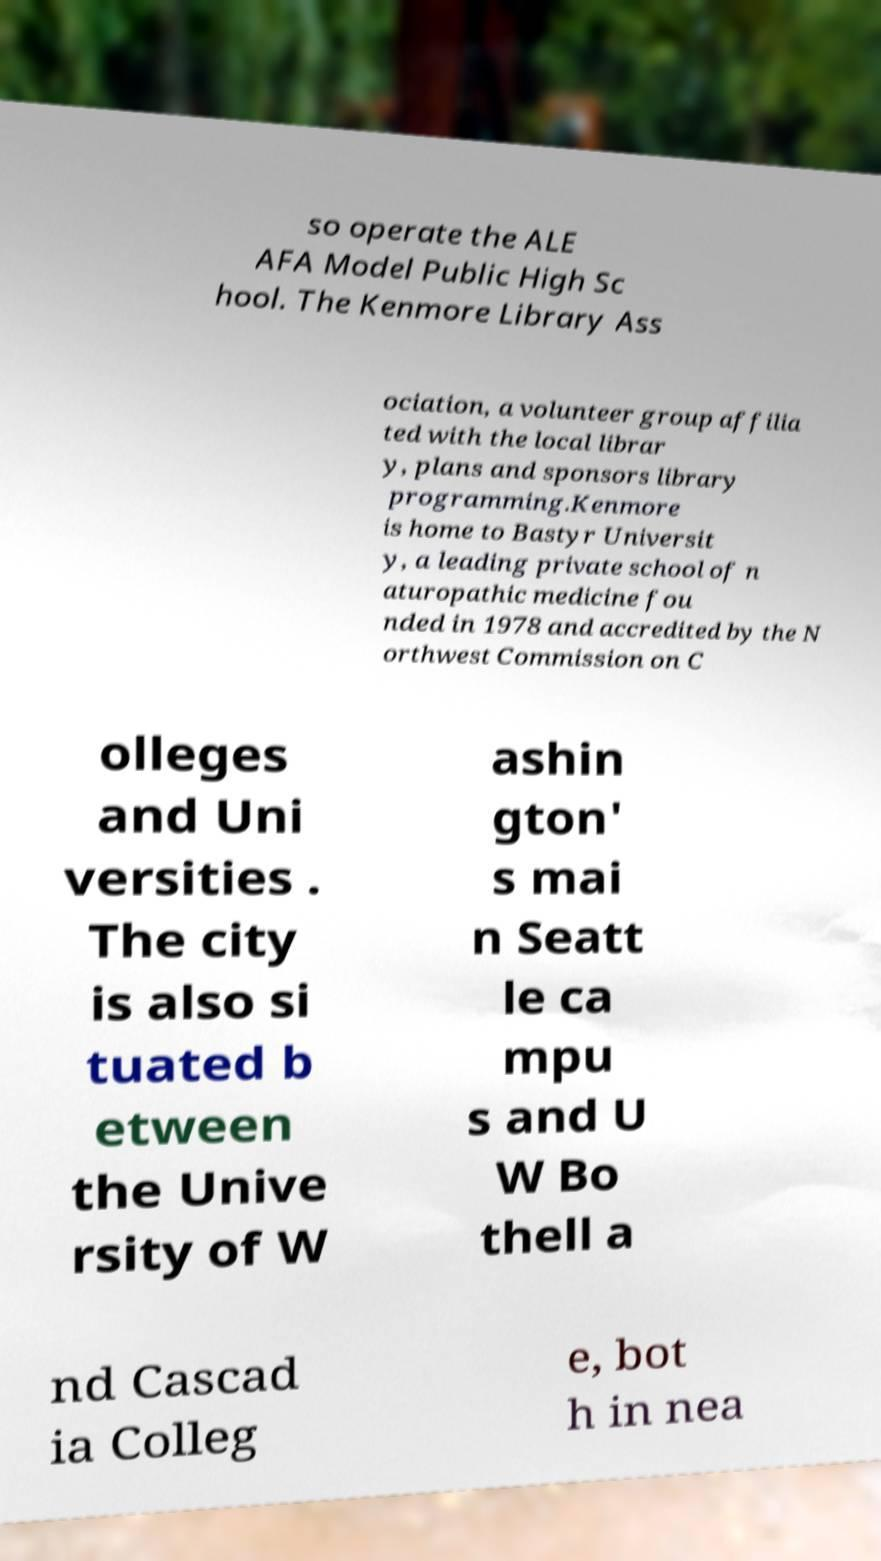Could you extract and type out the text from this image? so operate the ALE AFA Model Public High Sc hool. The Kenmore Library Ass ociation, a volunteer group affilia ted with the local librar y, plans and sponsors library programming.Kenmore is home to Bastyr Universit y, a leading private school of n aturopathic medicine fou nded in 1978 and accredited by the N orthwest Commission on C olleges and Uni versities . The city is also si tuated b etween the Unive rsity of W ashin gton' s mai n Seatt le ca mpu s and U W Bo thell a nd Cascad ia Colleg e, bot h in nea 